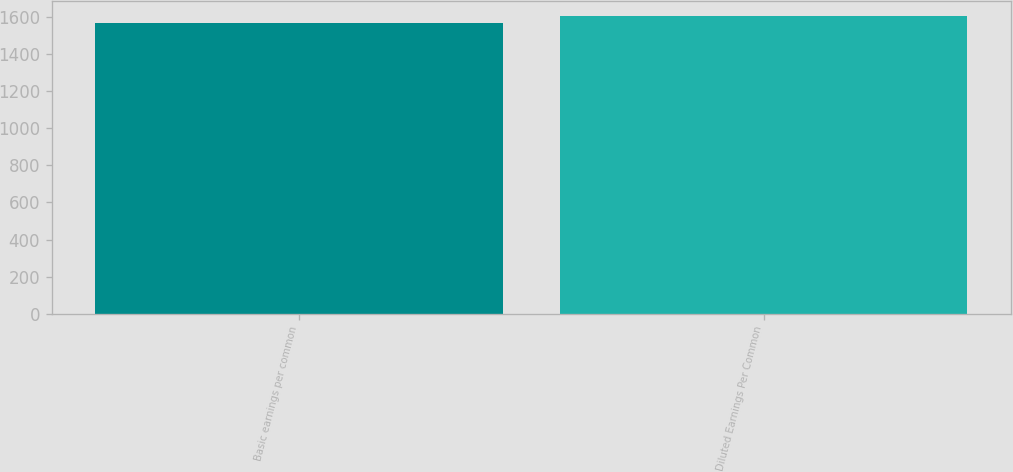<chart> <loc_0><loc_0><loc_500><loc_500><bar_chart><fcel>Basic earnings per common<fcel>Diluted Earnings Per Common<nl><fcel>1566<fcel>1603<nl></chart> 